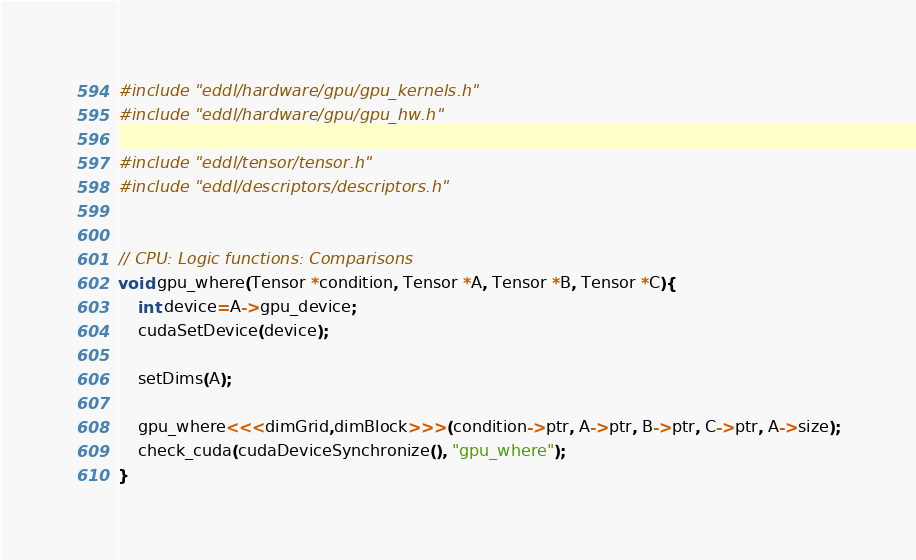Convert code to text. <code><loc_0><loc_0><loc_500><loc_500><_Cuda_>#include "eddl/hardware/gpu/gpu_kernels.h"
#include "eddl/hardware/gpu/gpu_hw.h"

#include "eddl/tensor/tensor.h"
#include "eddl/descriptors/descriptors.h"


// CPU: Logic functions: Comparisons
void gpu_where(Tensor *condition, Tensor *A, Tensor *B, Tensor *C){
    int device=A->gpu_device;
    cudaSetDevice(device);

    setDims(A);

    gpu_where<<<dimGrid,dimBlock>>>(condition->ptr, A->ptr, B->ptr, C->ptr, A->size);
    check_cuda(cudaDeviceSynchronize(), "gpu_where");
}
</code> 